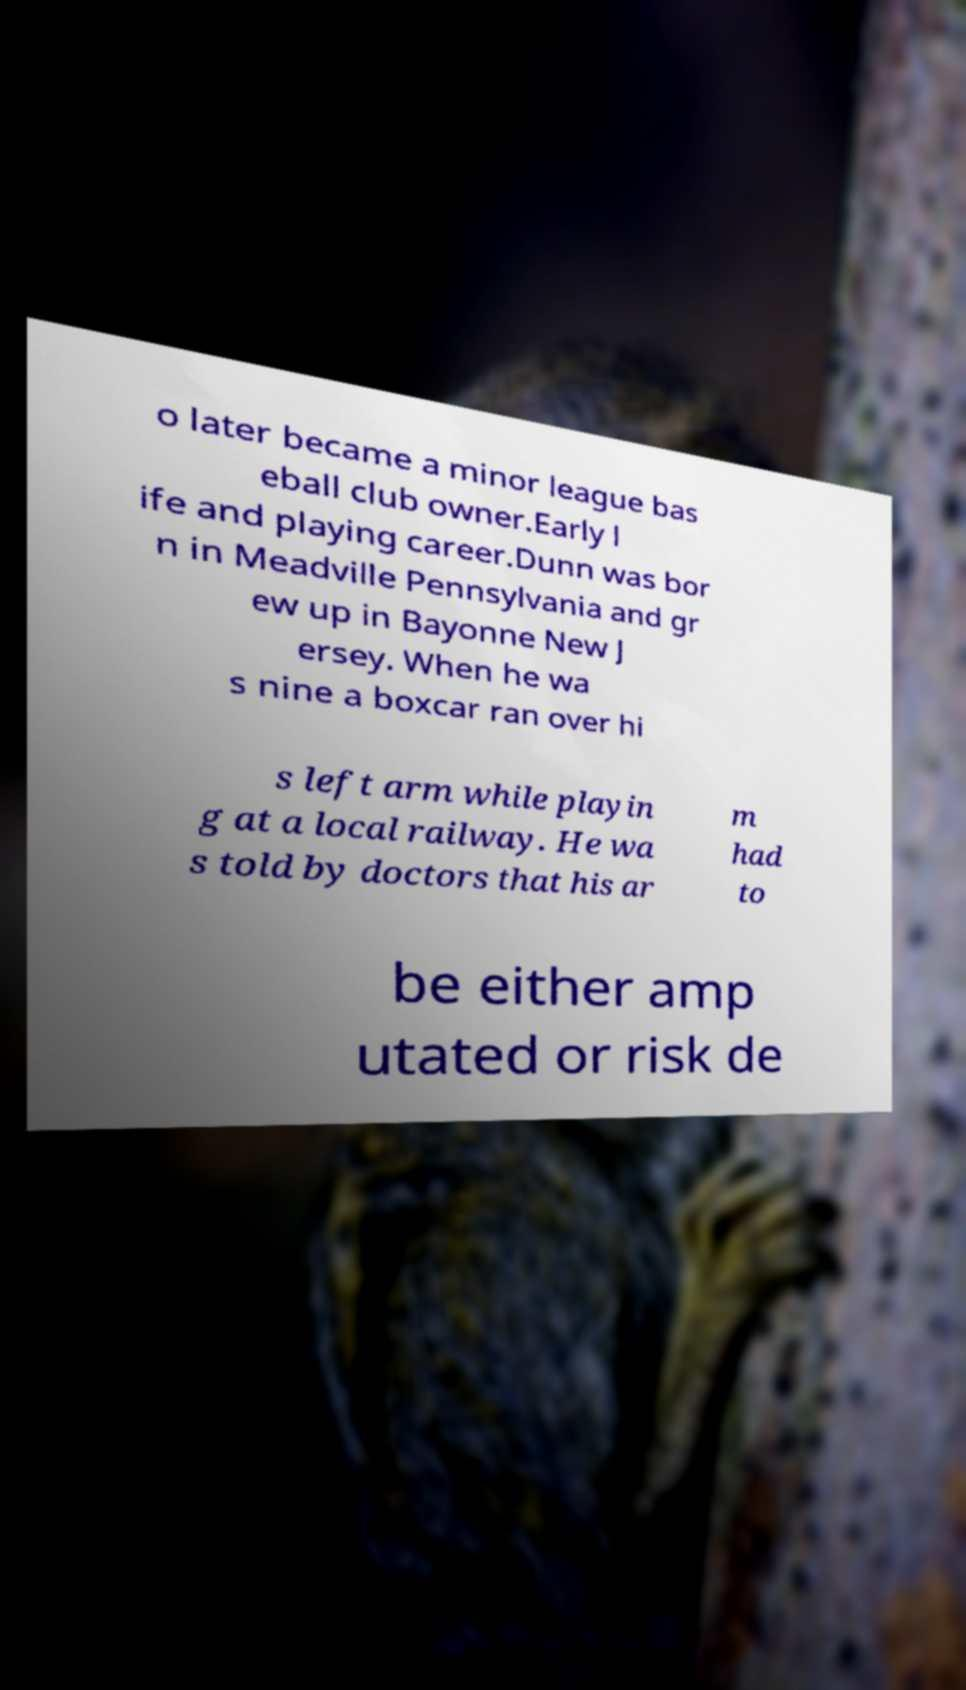I need the written content from this picture converted into text. Can you do that? o later became a minor league bas eball club owner.Early l ife and playing career.Dunn was bor n in Meadville Pennsylvania and gr ew up in Bayonne New J ersey. When he wa s nine a boxcar ran over hi s left arm while playin g at a local railway. He wa s told by doctors that his ar m had to be either amp utated or risk de 